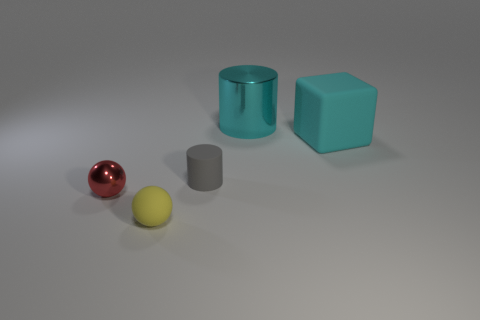What size is the matte object that is the same color as the metallic cylinder?
Offer a very short reply. Large. How many other things are the same size as the cyan rubber object?
Make the answer very short. 1. Is the color of the big rubber block the same as the metal object in front of the small gray matte cylinder?
Your answer should be compact. No. Is the number of red balls that are in front of the tiny red sphere less than the number of large metallic objects to the left of the gray thing?
Give a very brief answer. No. The matte thing that is both left of the big cube and to the right of the tiny yellow rubber ball is what color?
Make the answer very short. Gray. Do the gray rubber cylinder and the rubber object on the right side of the large cyan shiny cylinder have the same size?
Provide a succinct answer. No. There is a small matte object on the left side of the rubber cylinder; what shape is it?
Offer a very short reply. Sphere. Are there any other things that have the same material as the block?
Offer a terse response. Yes. Is the number of rubber blocks behind the cube greater than the number of big cyan things?
Ensure brevity in your answer.  No. There is a tiny object that is in front of the thing that is left of the tiny rubber ball; what number of objects are left of it?
Ensure brevity in your answer.  1. 